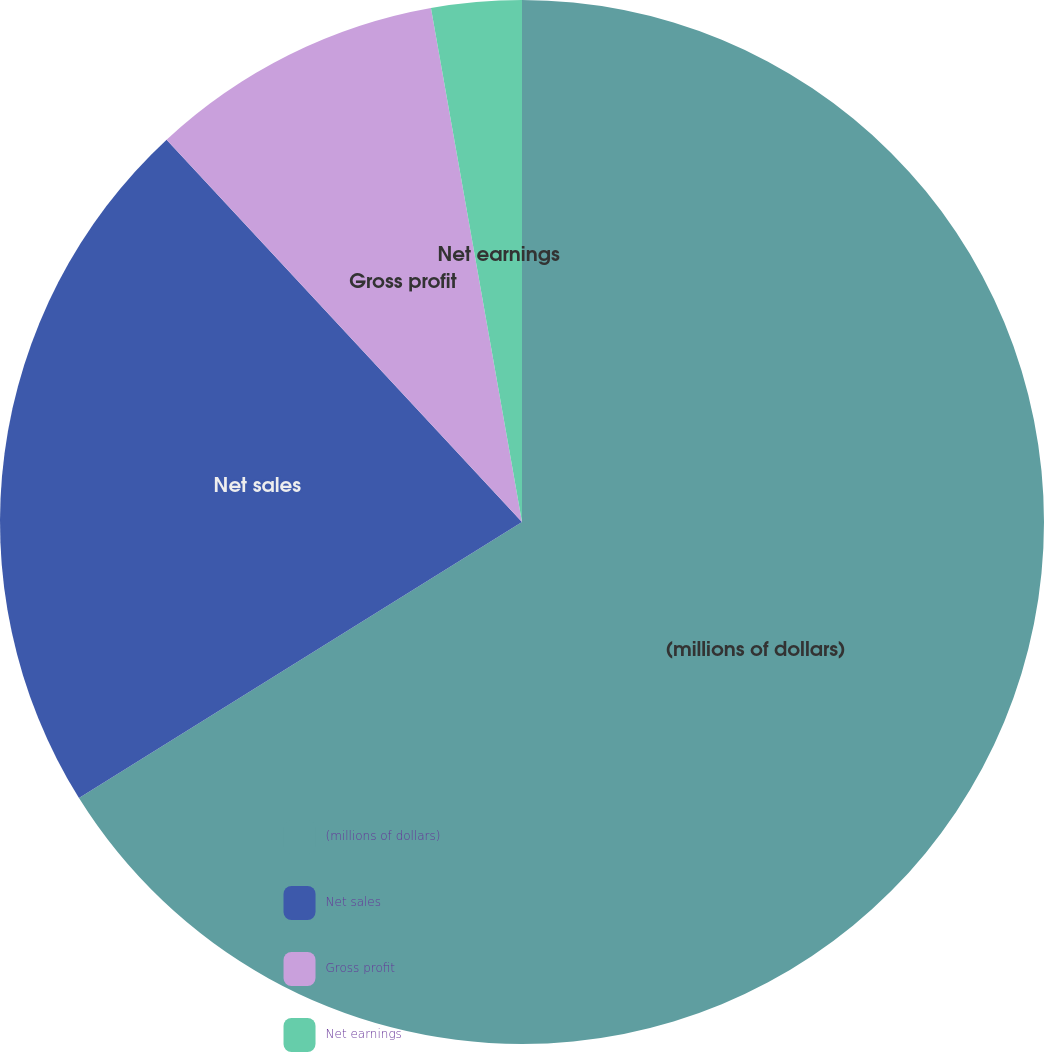<chart> <loc_0><loc_0><loc_500><loc_500><pie_chart><fcel>(millions of dollars)<fcel>Net sales<fcel>Gross profit<fcel>Net earnings<nl><fcel>66.13%<fcel>21.95%<fcel>9.13%<fcel>2.79%<nl></chart> 